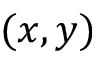Convert formula to latex. <formula><loc_0><loc_0><loc_500><loc_500>( x , y )</formula> 